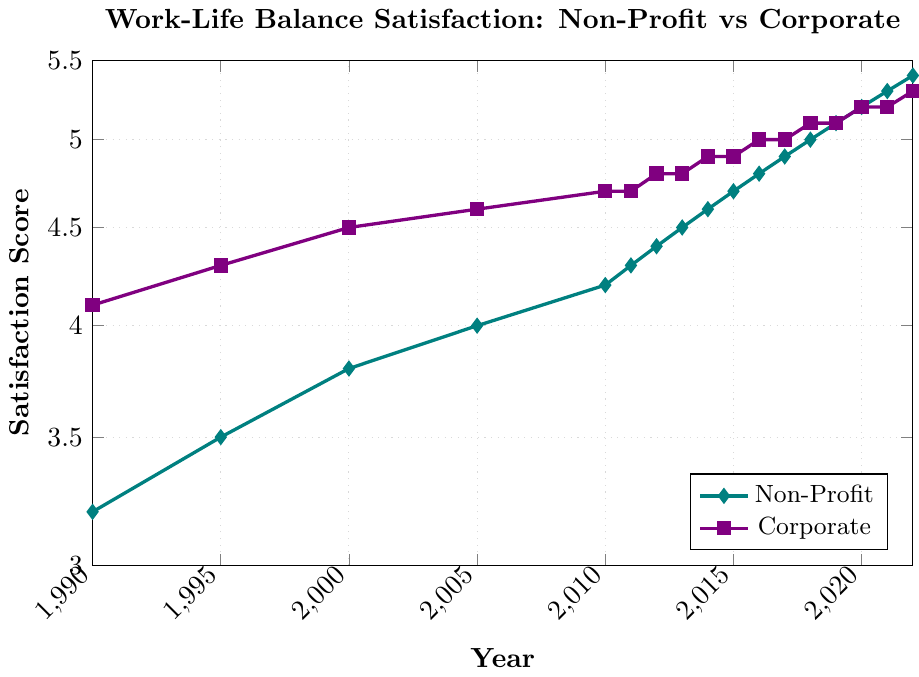How did the work-life balance satisfaction scores for non-profit professionals change from 1990 to 2022? First, identify the 1990 value for non-profit satisfaction, which is 3.2. Then, identify the 2022 value for non-profit satisfaction, which is 5.4. Calculate the change by subtracting the 1990 value from the 2022 value: 5.4 - 3.2 = 2.2.
Answer: The satisfaction increased by 2.2 points In which year did non-profit professionals achieve a satisfaction score above 4.0 for the first time? Look at the non-profit satisfaction scores over the years and find the first year the score exceeds 4.0. The value is 4.2 in the year 2010.
Answer: 2010 By how much did the corporate executives' satisfaction score exceed the non-profit professionals' score in 1990? Identify the 1990 values for both corporate and non-profit satisfaction. Corporate satisfaction in 1990 is 4.1, and non-profit satisfaction is 3.2. The difference is 4.1 - 3.2 = 0.9.
Answer: 0.9 Compare the satisfaction trends for non-profit professionals and corporate executives. How did their trends differ from 2005 to 2022? Evaluate the satisfaction score trends for both groups from 2005 to 2022. Non-profit scores increase consistently from 4.0 to 5.4, whereas corporate scores make smaller increments from 4.6 to 5.3, flattening around 2018. This shows non-profits had a steeper increase.
Answer: Non-profits had a steeper increase What was the average satisfaction score for corporate executives from 2010 to 2022? Identify the satisfaction values for corporate executives from 2010 to 2022 (4.7, 4.7, 4.8, 4.8, 4.9, 4.9, 5.0, 5.0, 5.1, 5.1, 5.2, 5.2, 5.3). Sum these values: 4.7 + 4.7 + 4.8 + 4.8 + 4.9 + 4.9 + 5.0 + 5.0 + 5.1 + 5.1 + 5.2 + 5.2 + 5.3 = 64.7. Divide by the number of years (13): 64.7 / 13 ≈ 4.98.
Answer: Approximately 4.98 In which years did the non-profit professionals see an increase of exactly 0.1 in their satisfaction scores year-on-year? Identify the yearly increments in non-profit satisfaction scores and find years with exactly 0.1 increments. These years are 2011 (4.3 from 4.2), 2012 (4.4 from 4.3), 2014 (4.6 from 4.5), 2015 (4.7 from 4.6), and 2021 (5.3 from 5.2).
Answer: 2011, 2012, 2014, 2015, 2021 How many years did corporate executives maintain the same satisfaction score with no increase or decrease? Evaluate corporate satisfaction scores and identify years where the score did not change from the previous year. These are 2010 to 2011 (4.7), 2012 to 2013 (4.8), 2014 to 2015 (4.9), and 2017 to 2018 (5.0), 2019 to 2020 (5.1), 2020 to 2021 (5.2). Count these instances: 6 years.
Answer: 6 years Which group had a higher satisfaction score in 2017, and by how much? Identify the 2017 values for both groups. Non-profit satisfaction is 4.9, and corporate satisfaction is 5.0. Calculate the difference: 5.0 - 4.9 = 0.1, with corporate being higher.
Answer: Corporate was higher by 0.1 points Between which consecutive years did the non-profit professionals experience the greatest increase in satisfaction scores? Look at the year-on-year increments for non-profit satisfaction. The largest jump is from 2010 (4.2) to 2011 (4.3), from 5.0 to 5.2 in 2019 to 2020, and 5.3 to 5.4 in 2021 to 2022 all at 0.2 increase.
Answer: Each of 2010-2011, 2019-2020, 2021-2022 with 0.2 What is the color representing non-profit satisfaction scores in the plot? Identify the line color used in the plot for the non-profit satisfaction scores by referring to the visual elements. The plot indicates it is depicted in teal color.
Answer: Teal 